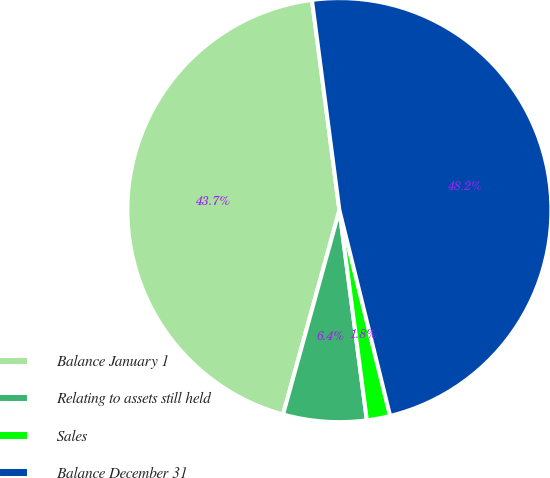Convert chart to OTSL. <chart><loc_0><loc_0><loc_500><loc_500><pie_chart><fcel>Balance January 1<fcel>Relating to assets still held<fcel>Sales<fcel>Balance December 31<nl><fcel>43.65%<fcel>6.35%<fcel>1.78%<fcel>48.22%<nl></chart> 